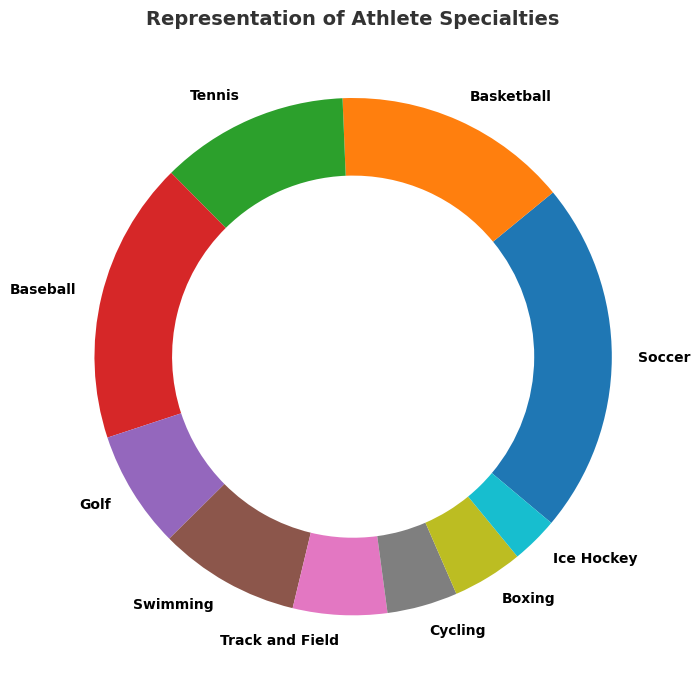What's the sport with the largest representation in your client roster? Look for the sport segment with the highest percentage. Soccer has the largest segment at 25%.
Answer: Soccer Which two sports have the smallest representation in your client roster? Identify the two smallest segments. Ice Hockey and Cycling both have small segments.
Answer: Ice Hockey and Cycling How many athletes are represented in total? Sum the counts of athletes across all sports: 15 + 10 + 8 + 12 + 5 + 6 + 4 + 3 + 3 + 2 = 68.
Answer: 68 What is the combined percentage of Soccer, Basketball, and Tennis athletes? Add the individual percentages of the three sports. 25% (Soccer) + 14.7% (Basketball) + 11.8% (Tennis) = 51.5%.
Answer: 51.5% Which sport has a higher representation, Baseball or Tennis, and by how much? Compare the two percentages. Baseball has 17.6% and Tennis has 11.8%. The difference is 17.6% - 11.8% = 5.8%.
Answer: Baseball by 5.8% What's the average representation percentage per sport? Total percentage is 100%. There are 10 sports: 100% / 10 = 10%.
Answer: 10% How does the representation of Swimming compare to Golf? Compare the percentages of Swimming (8.8%) and Golf (7.4%). Swimming has a slightly larger segment.
Answer: Swimming has more How many sports have a representation greater than 10%? Identify sports with a percentage greater than 10%. Soccer (25%), Basketball (14.7%), Baseball (17.6%), Tennis (11.8%). 4 sports.
Answer: 4 Which sport represents exactly 5 athletes? Find the segment associated with 5 athletes. Golf represents 5 athletes.
Answer: Golf What is the combined representation of individual sports with fewer than 5 athletes? Add the percentages for sports with 3 or fewer athletes: Cycling (4.4%) + Boxing (4.4%) + Ice Hockey (2.9%) = 4.4% + 4.4% + 2.9% = 11.7%.
Answer: 11.7% 